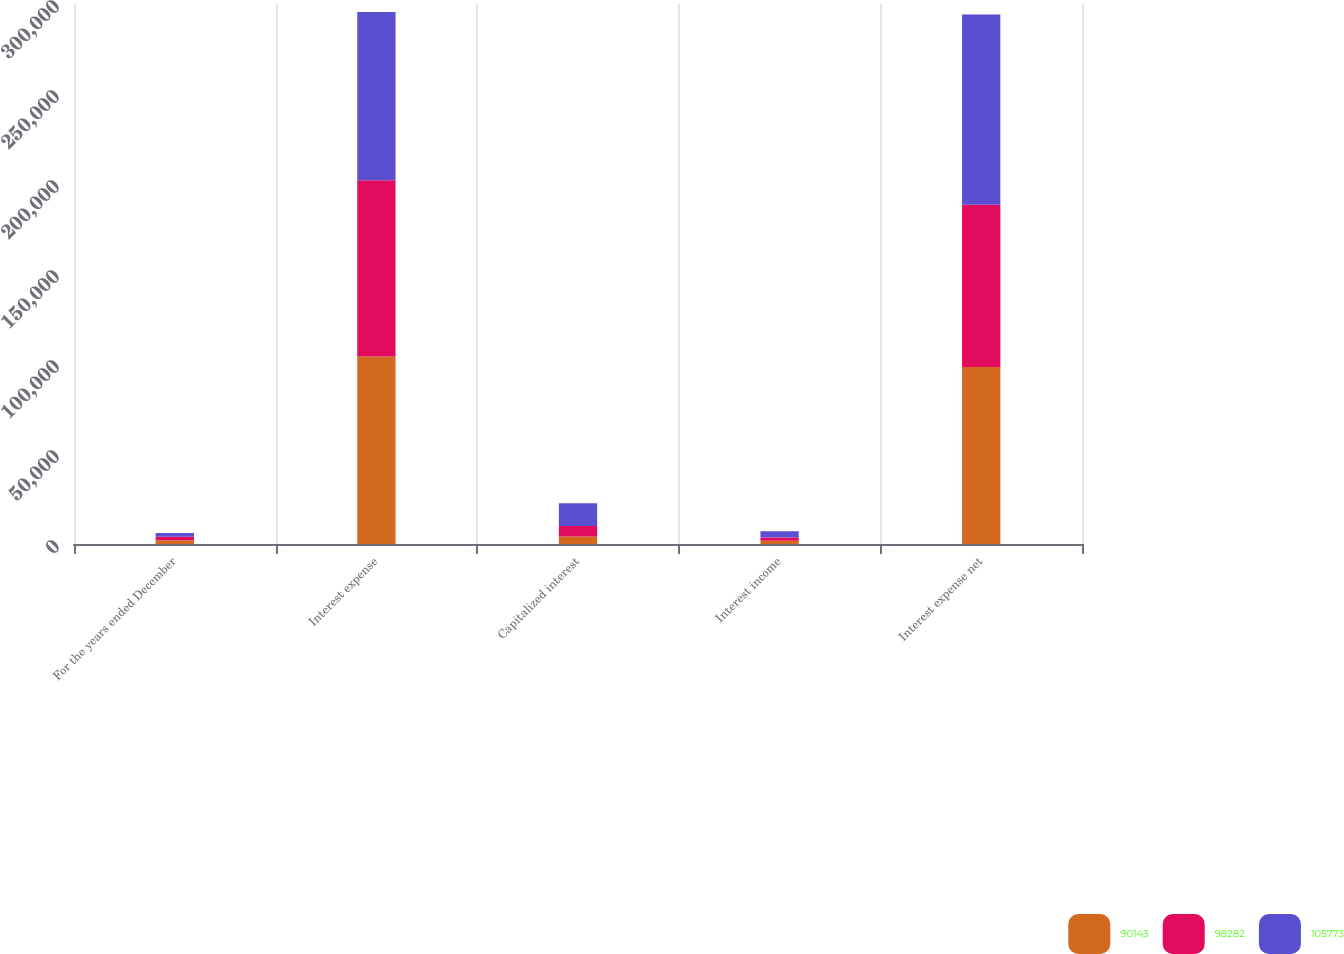<chart> <loc_0><loc_0><loc_500><loc_500><stacked_bar_chart><ecel><fcel>For the years ended December<fcel>Interest expense<fcel>Capitalized interest<fcel>Interest income<fcel>Interest expense net<nl><fcel>90143<fcel>2017<fcel>104232<fcel>4166<fcel>1784<fcel>98282<nl><fcel>98282<fcel>2016<fcel>97851<fcel>5903<fcel>1805<fcel>90143<nl><fcel>105773<fcel>2015<fcel>93520<fcel>12537<fcel>3536<fcel>105773<nl></chart> 